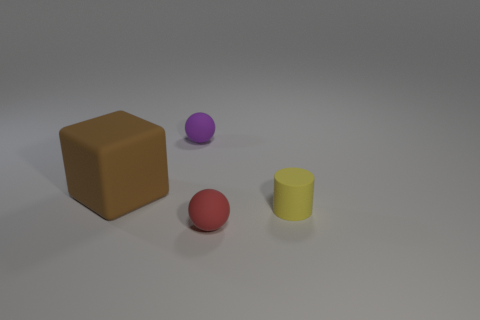What might be the context or use for these objects in the real world? These objects appear to be simple geometric shapes often used in educational contexts to help children learn about different shapes and colors. Additionally, they could be used in a design or art setting for creating abstract compositions. 